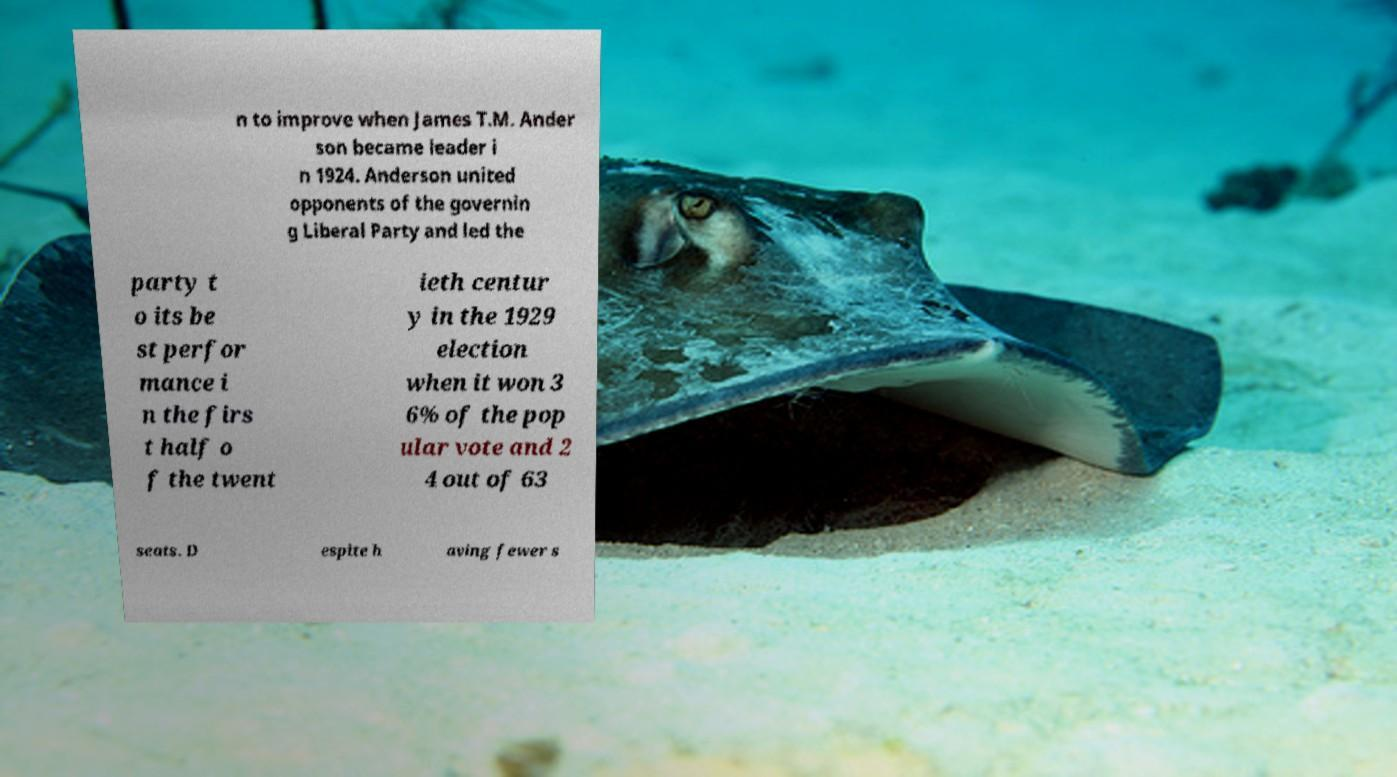Can you read and provide the text displayed in the image?This photo seems to have some interesting text. Can you extract and type it out for me? n to improve when James T.M. Ander son became leader i n 1924. Anderson united opponents of the governin g Liberal Party and led the party t o its be st perfor mance i n the firs t half o f the twent ieth centur y in the 1929 election when it won 3 6% of the pop ular vote and 2 4 out of 63 seats. D espite h aving fewer s 